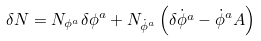Convert formula to latex. <formula><loc_0><loc_0><loc_500><loc_500>\delta N = N _ { \phi ^ { a } } \delta \phi ^ { a } + N _ { \dot { \phi } ^ { a } } \left ( \dot { \delta \phi ^ { a } } - \dot { \phi } ^ { a } A \right )</formula> 